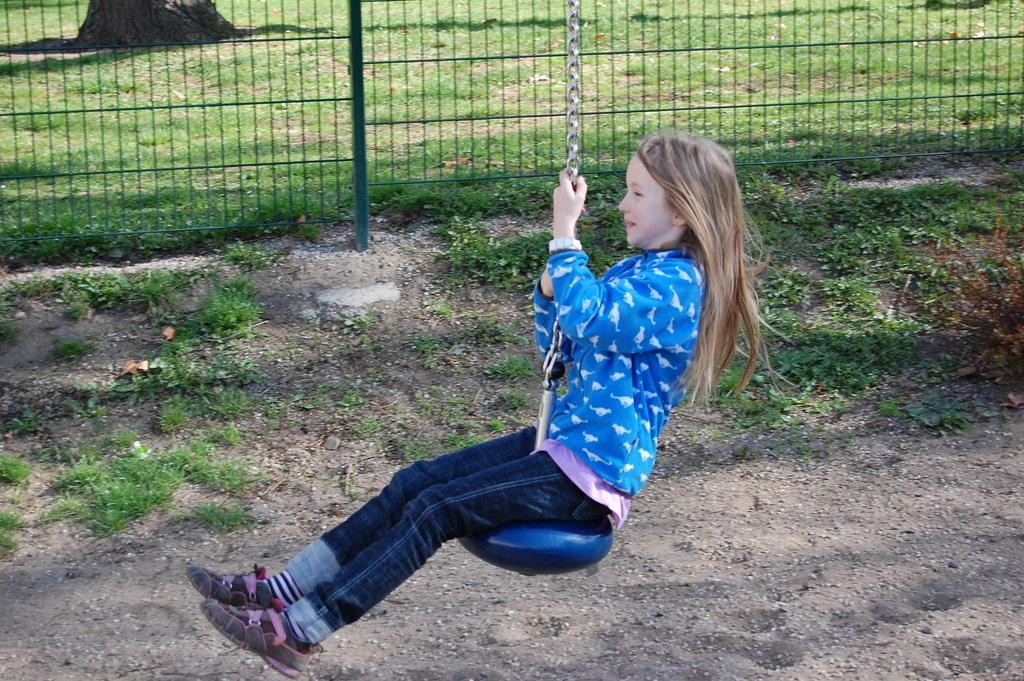Please provide a concise description of this image. In this image in the front there is a girl sitting on swing and smiling. In the background there is grass on the ground and there is a fence and there is a tree trunk which is visible. 